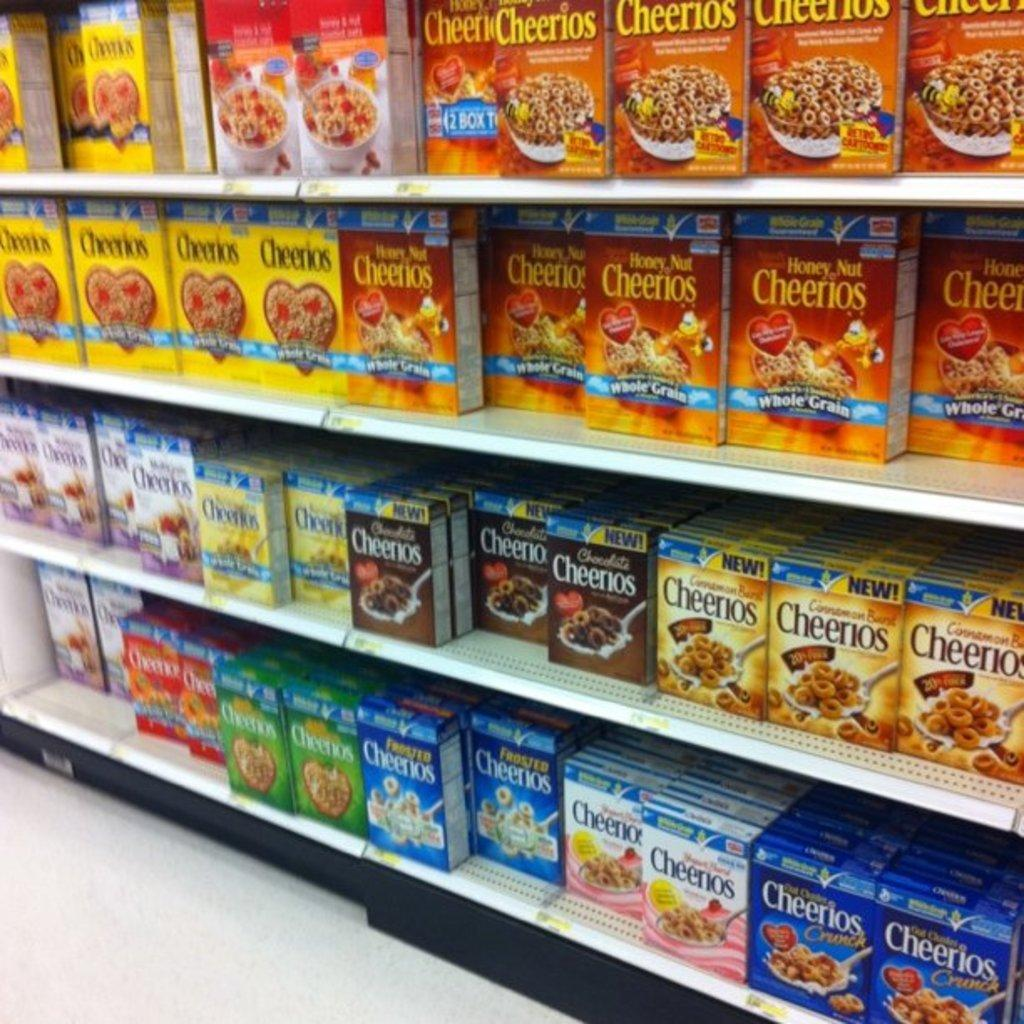Provide a one-sentence caption for the provided image. Boxes of different flavors of Cheerios on the shelves. 